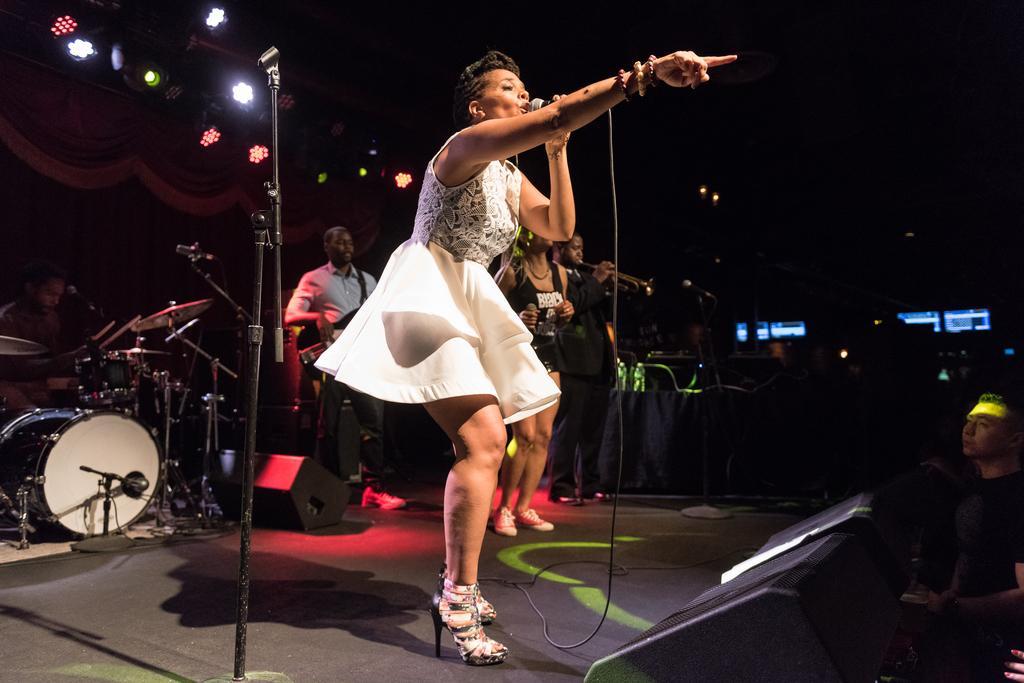Please provide a concise description of this image. It seems like a musical concert is going on. A lady wearing white dress is singing she is holding a mic. Behind her musicians are playing musical instruments. In the background there are lights. In front of the lady many people are standing watching her. 